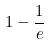Convert formula to latex. <formula><loc_0><loc_0><loc_500><loc_500>1 - \frac { 1 } { e }</formula> 